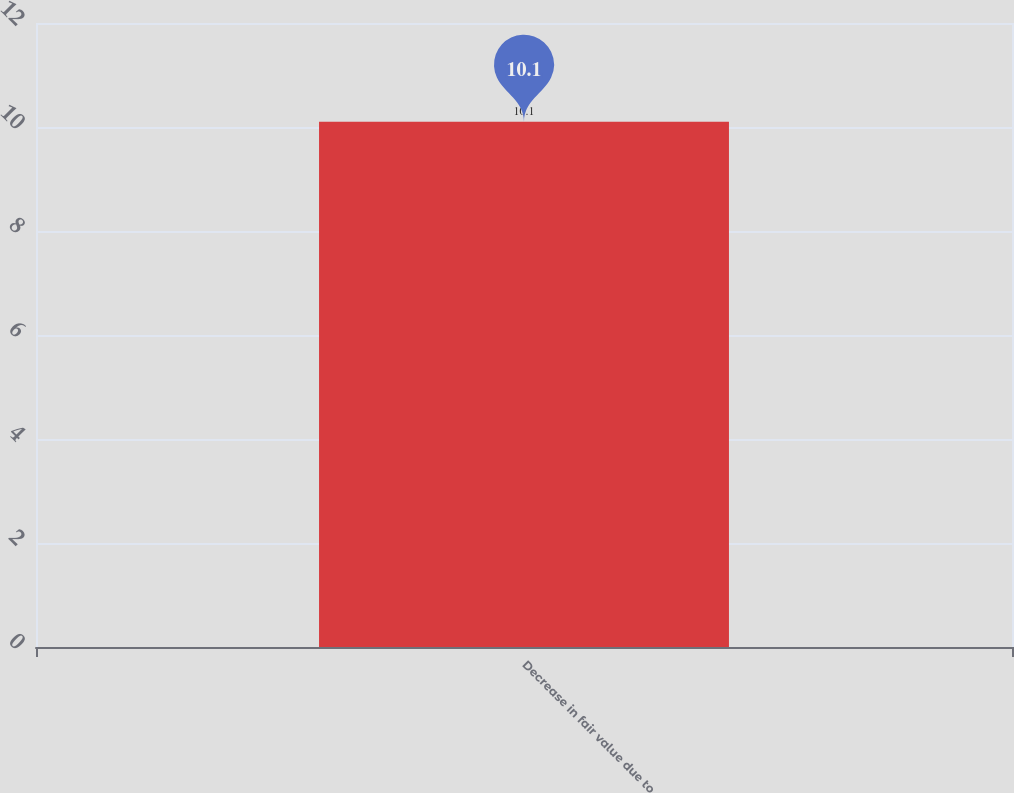Convert chart. <chart><loc_0><loc_0><loc_500><loc_500><bar_chart><fcel>Decrease in fair value due to<nl><fcel>10.1<nl></chart> 